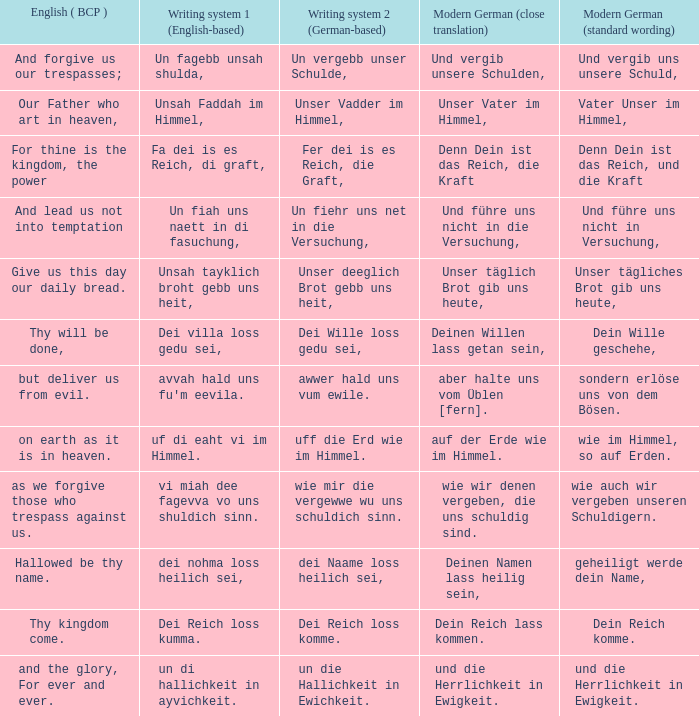What is the modern german standard wording for the german based writing system 2 phrase "wie mir die vergewwe wu uns schuldich sinn."? Wie auch wir vergeben unseren schuldigern. 